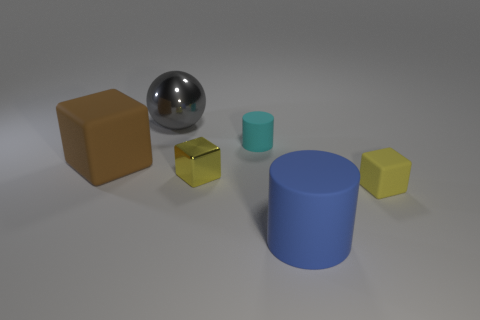Add 4 cyan rubber cylinders. How many objects exist? 10 Subtract all spheres. How many objects are left? 5 Subtract all tiny purple metallic cylinders. Subtract all big blue objects. How many objects are left? 5 Add 4 small yellow metal things. How many small yellow metal things are left? 5 Add 2 large gray blocks. How many large gray blocks exist? 2 Subtract 0 gray cylinders. How many objects are left? 6 